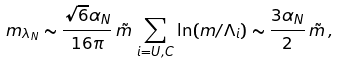Convert formula to latex. <formula><loc_0><loc_0><loc_500><loc_500>m _ { \lambda _ { N } } \sim \frac { \sqrt { 6 } \alpha _ { N } } { 1 6 \pi } \, \tilde { m } \, \sum _ { i = U , C } \ln ( m / \Lambda _ { i } ) \sim \frac { 3 \alpha _ { N } } { 2 } \, \tilde { m } \, ,</formula> 